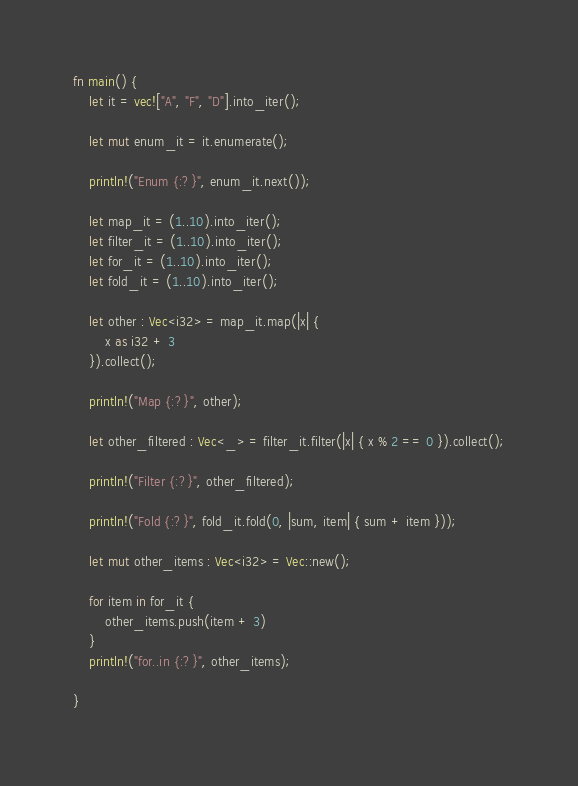<code> <loc_0><loc_0><loc_500><loc_500><_Rust_>fn main() {
    let it = vec!["A", "F", "D"].into_iter();

    let mut enum_it = it.enumerate();

    println!("Enum {:?}", enum_it.next());

    let map_it = (1..10).into_iter();
    let filter_it = (1..10).into_iter();
    let for_it = (1..10).into_iter();
    let fold_it = (1..10).into_iter();

    let other : Vec<i32> = map_it.map(|x| {
        x as i32 + 3
    }).collect();

    println!("Map {:?}", other);

    let other_filtered : Vec<_> = filter_it.filter(|x| { x % 2 == 0 }).collect();

    println!("Filter {:?}", other_filtered);

    println!("Fold {:?}", fold_it.fold(0, |sum, item| { sum + item }));

    let mut other_items : Vec<i32> = Vec::new();

    for item in for_it {
        other_items.push(item + 3)
    }
    println!("for..in {:?}", other_items);

}
</code> 